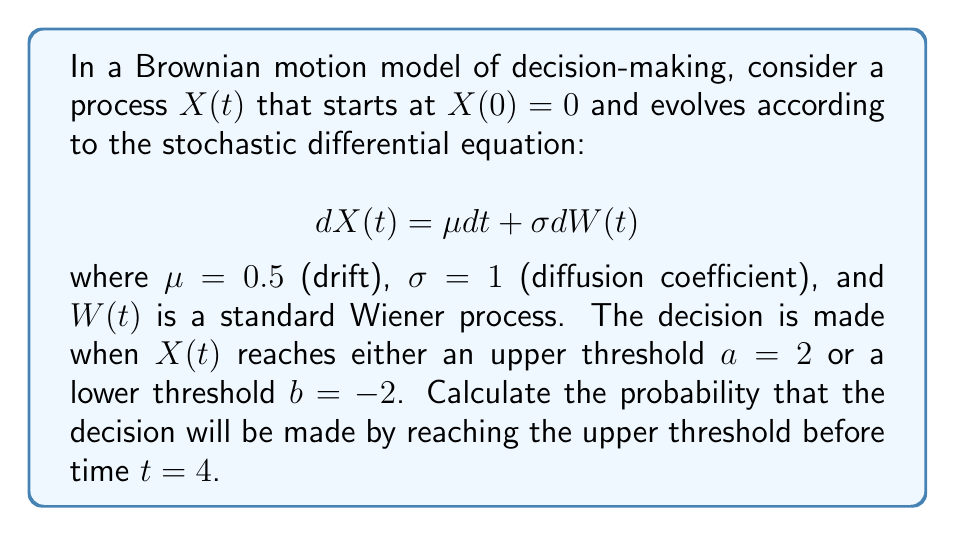Solve this math problem. To solve this problem, we need to analyze the first passage time distribution of the Brownian motion process. We'll follow these steps:

1) First, we recognize that this is a first passage time problem for a Brownian motion with drift. The probability we're looking for is related to the cumulative distribution function (CDF) of the first passage time to the upper boundary.

2) For a Brownian motion with drift $\mu$ and diffusion coefficient $\sigma$, starting at $x_0 = 0$, the probability of hitting the upper boundary $a$ before the lower boundary $b$ is given by:

   $$P(\text{hit } a \text{ before } b) = \frac{e^{-2\mu b/\sigma^2} - 1}{e^{-2\mu a/\sigma^2} - e^{-2\mu b/\sigma^2}}$$

3) Substituting our values: $\mu = 0.5$, $\sigma = 1$, $a = 2$, $b = -2$:

   $$P(\text{hit } 2 \text{ before } -2) = \frac{e^{2} - 1}{e^{-2} - e^{2}} \approx 0.9241$$

4) This gives us the overall probability of reaching the upper threshold, but we need to consider the time constraint.

5) The cumulative distribution function of the first passage time to the upper boundary $a$ for a Brownian motion with drift is given by:

   $$F(t) = \Phi\left(\frac{a - \mu t}{\sigma \sqrt{t}}\right) + e^{2\mu a/\sigma^2}\Phi\left(\frac{-a - \mu t}{\sigma \sqrt{t}}\right)$$

   where $\Phi(x)$ is the standard normal CDF.

6) Substituting our values and $t = 4$:

   $$F(4) = \Phi\left(\frac{2 - 0.5 \cdot 4}{1 \cdot \sqrt{4}}\right) + e^{2\cdot0.5\cdot2/1^2}\Phi\left(\frac{-2 - 0.5 \cdot 4}{1 \cdot \sqrt{4}}\right)$$

7) Simplifying:

   $$F(4) = \Phi(0) + e^2\Phi(-2) \approx 0.5 + 7.3891 \cdot 0.0228 \approx 0.6684$$

8) However, this probability includes all paths that reach the upper threshold by time 4, including those that may have crossed the lower threshold first. We need to adjust for this.

9) The probability we're looking for is the product of the probability of hitting the upper threshold before the lower threshold (step 3) and the probability of reaching the upper threshold by time 4 (step 7):

   $$P(\text{hit } 2 \text{ before } -2 \text{ and before } t=4) = 0.9241 \cdot 0.6684 \approx 0.6177$$
Answer: 0.6177 